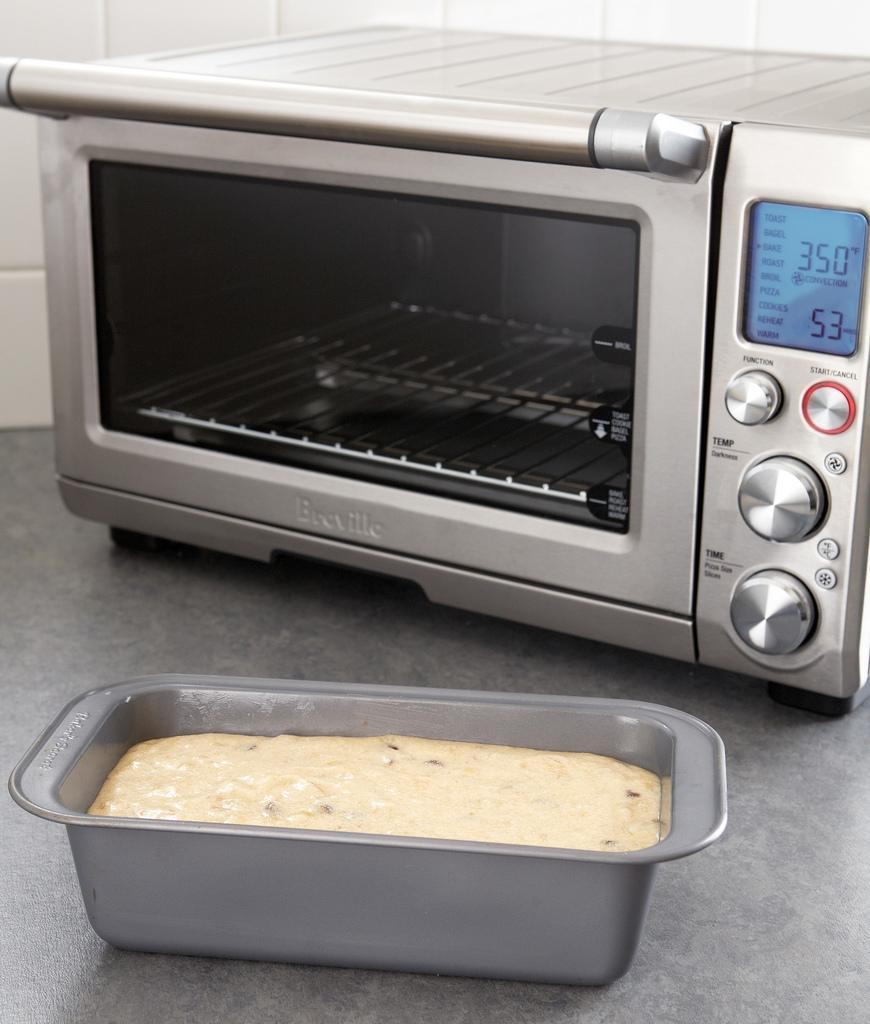Provide a one-sentence caption for the provided image. A breadpan sits in front of a toaster oven that displays 350 degrees F convection on its' digital screen. 